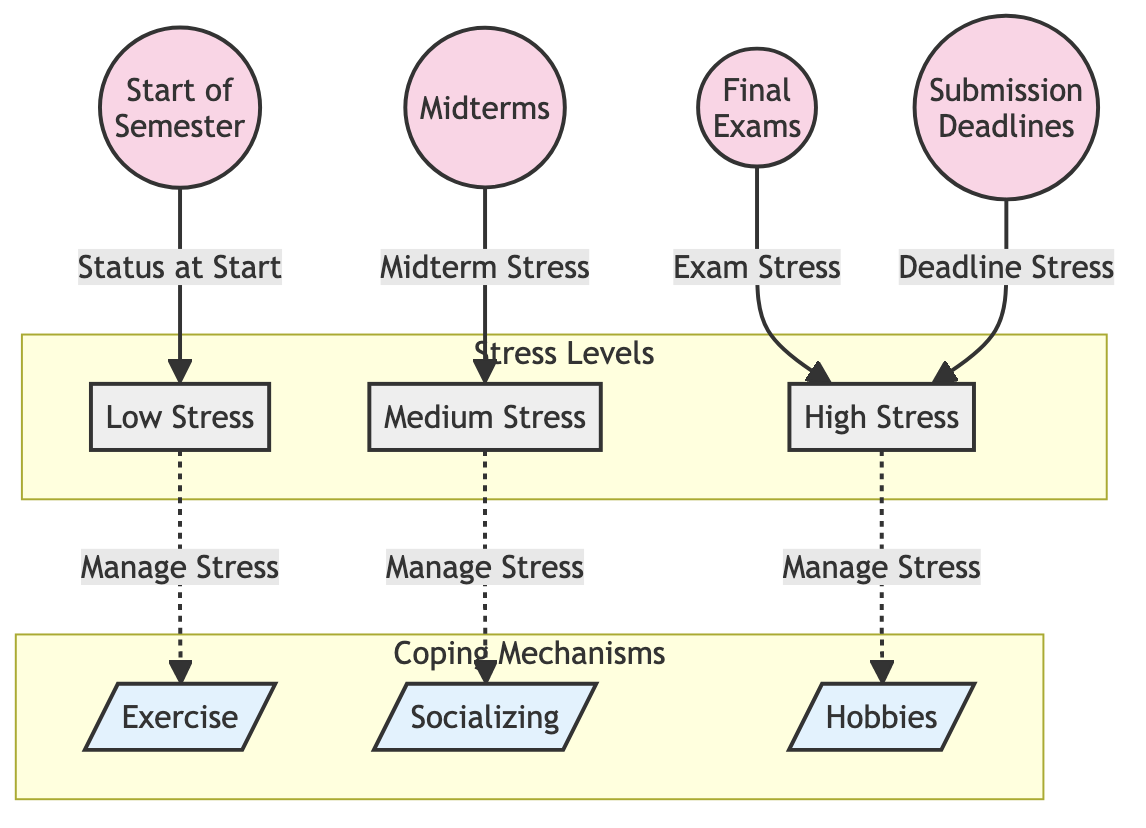What's the first node in the diagram? The first node, representing the start of the semester, is labeled "Start of Semester."
Answer: Start of Semester How many coping mechanisms are represented in the diagram? The diagram includes three coping mechanisms: exercise, socializing, and hobbies. Therefore, there are three mechanisms.
Answer: 3 What type of stress is depicted after midterms? The node that follows midterms is labeled "Medium Stress," indicating the stress level at that point.
Answer: Medium Stress Which stress level correlates with final exams? The diagram shows that the exam stress, represented by a node, correlates with "High Stress."
Answer: High Stress What is the relationship between low stress and exercise? The diagram indicates that there is a link where low stress can be managed through exercise, which connects them through a dashed line labeled "Manage Stress."
Answer: Manage Stress Which coping mechanism is associated with high stress levels? The coping mechanism connected to high stress levels is labeled "Hobbies," indicating that it is used to manage high stress.
Answer: Hobbies How does submission deadlines affect stress levels? Submission deadlines lead to "High Stress," indicating that approaching deadlines increase stress levels for students.
Answer: High Stress What node follows the "Start of Semester" in terms of stress? The first stress level after the start of the semester is labeled "Low Stress," representing initial feelings before academic pressures set in.
Answer: Low Stress Which coping mechanism is linked to medium stress? The diagram shows that "Socializing" is linked to medium stress, intended as a strategy to cope at that stress level.
Answer: Socializing 